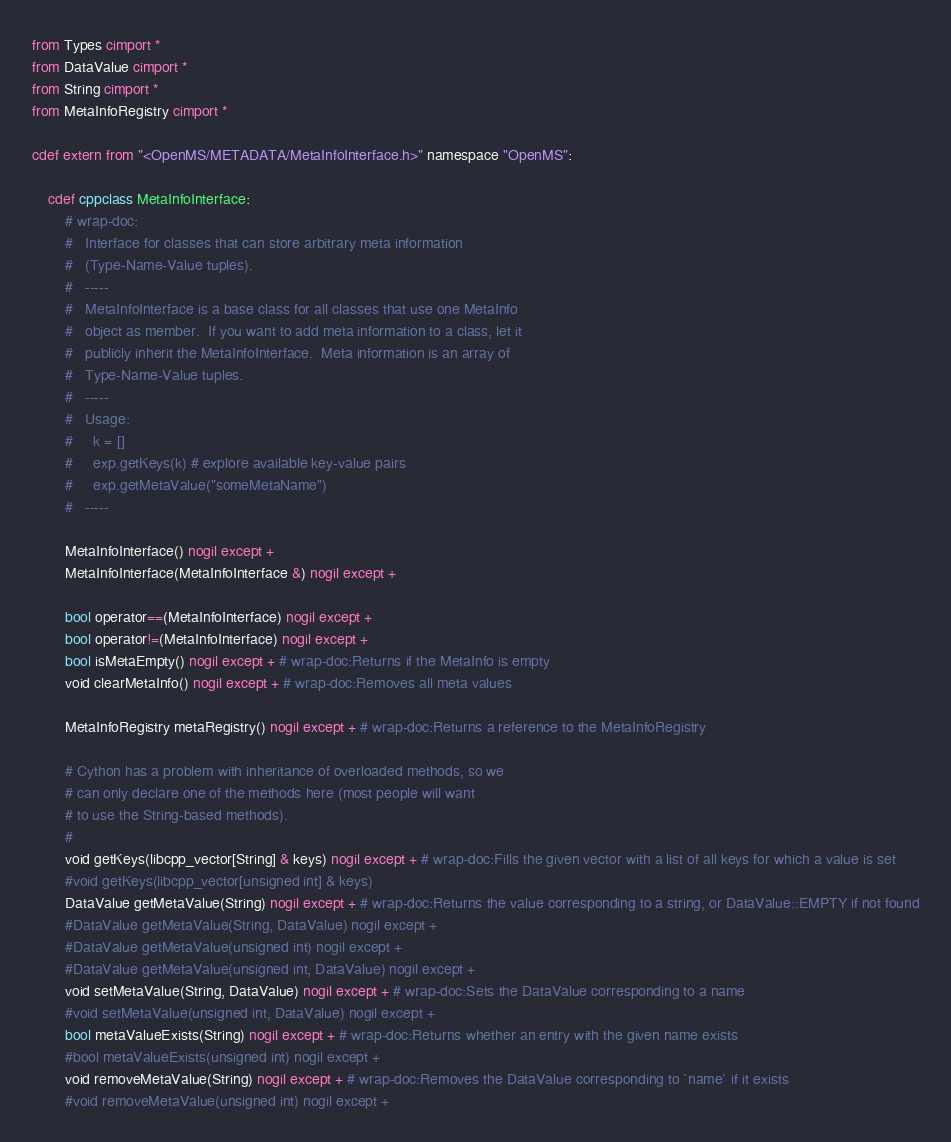Convert code to text. <code><loc_0><loc_0><loc_500><loc_500><_Cython_>from Types cimport *
from DataValue cimport *
from String cimport *
from MetaInfoRegistry cimport *

cdef extern from "<OpenMS/METADATA/MetaInfoInterface.h>" namespace "OpenMS":

    cdef cppclass MetaInfoInterface:
        # wrap-doc:
        #   Interface for classes that can store arbitrary meta information
        #   (Type-Name-Value tuples).
        #   -----
        #   MetaInfoInterface is a base class for all classes that use one MetaInfo
        #   object as member.  If you want to add meta information to a class, let it
        #   publicly inherit the MetaInfoInterface.  Meta information is an array of
        #   Type-Name-Value tuples.
        #   -----
        #   Usage:
        #     k = []
        #     exp.getKeys(k) # explore available key-value pairs
        #     exp.getMetaValue("someMetaName")
        #   -----

        MetaInfoInterface() nogil except +
        MetaInfoInterface(MetaInfoInterface &) nogil except +

        bool operator==(MetaInfoInterface) nogil except +
        bool operator!=(MetaInfoInterface) nogil except +
        bool isMetaEmpty() nogil except + # wrap-doc:Returns if the MetaInfo is empty
        void clearMetaInfo() nogil except + # wrap-doc:Removes all meta values

        MetaInfoRegistry metaRegistry() nogil except + # wrap-doc:Returns a reference to the MetaInfoRegistry

        # Cython has a problem with inheritance of overloaded methods, so we
        # can only declare one of the methods here (most people will want
        # to use the String-based methods).
        #
        void getKeys(libcpp_vector[String] & keys) nogil except + # wrap-doc:Fills the given vector with a list of all keys for which a value is set
        #void getKeys(libcpp_vector[unsigned int] & keys)
        DataValue getMetaValue(String) nogil except + # wrap-doc:Returns the value corresponding to a string, or DataValue::EMPTY if not found
        #DataValue getMetaValue(String, DataValue) nogil except +
        #DataValue getMetaValue(unsigned int) nogil except +
        #DataValue getMetaValue(unsigned int, DataValue) nogil except +
        void setMetaValue(String, DataValue) nogil except + # wrap-doc:Sets the DataValue corresponding to a name
        #void setMetaValue(unsigned int, DataValue) nogil except +
        bool metaValueExists(String) nogil except + # wrap-doc:Returns whether an entry with the given name exists
        #bool metaValueExists(unsigned int) nogil except +
        void removeMetaValue(String) nogil except + # wrap-doc:Removes the DataValue corresponding to `name` if it exists
        #void removeMetaValue(unsigned int) nogil except +

</code> 